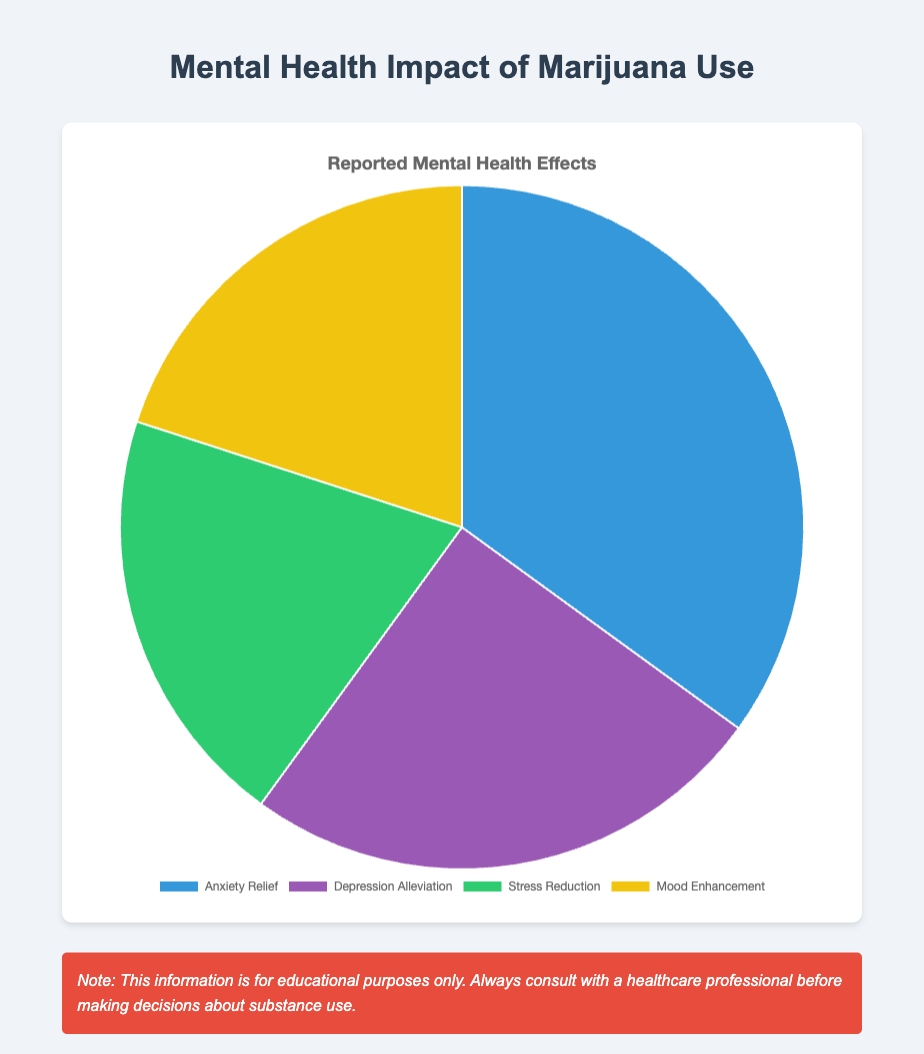What is the largest category in the pie chart? The largest category can be identified by looking for the section with the highest percentage. In this case, it is "Anxiety Relief" with 35%.
Answer: Anxiety Relief How much larger is "Anxiety Relief" compared to "Depression Alleviation"? To find out, subtract the percentage of "Depression Alleviation" (25%) from "Anxiety Relief" (35%). 35% - 25% = 10%.
Answer: 10% What is the combined percentage of "Stress Reduction" and "Mood Enhancement"? Add the percentages of "Stress Reduction" (20%) and "Mood Enhancement" (20%). 20% + 20% = 40%.
Answer: 40% Which two categories have the same percentage? By examining the pie chart, it's visible that "Stress Reduction" and "Mood Enhancement" both have a percentage of 20%.
Answer: Stress Reduction and Mood Enhancement What is the total percentage of mental health impacts related to anxiety and depression combined? Add the percentages of "Anxiety Relief" (35%) and "Depression Alleviation" (25%). 35% + 25% = 60%.
Answer: 60% Which category is visually represented by the green section in the pie chart? According to the color scheme usually provided, "Stress Reduction" is represented by the green section.
Answer: Stress Reduction Is "Mood Enhancement" a larger or smaller category than "Depression Alleviation"? Compare the percentages: "Mood Enhancement" is 20% and "Depression Alleviation" is 25%. Thus, "Mood Enhancement" is smaller.
Answer: Smaller What is the average percentage value of all four categories? Sum all the percentages and divide by the number of categories. (35 + 25 + 20 + 20)/4 = 25%.
Answer: 25% By how much does the "Mood Enhancement" category need to increase to match the "Anxiety Relief" category? Calculate the difference between "Anxiety Relief" (35%) and "Mood Enhancement" (20%). 35% - 20% = 15%.
Answer: 15% 